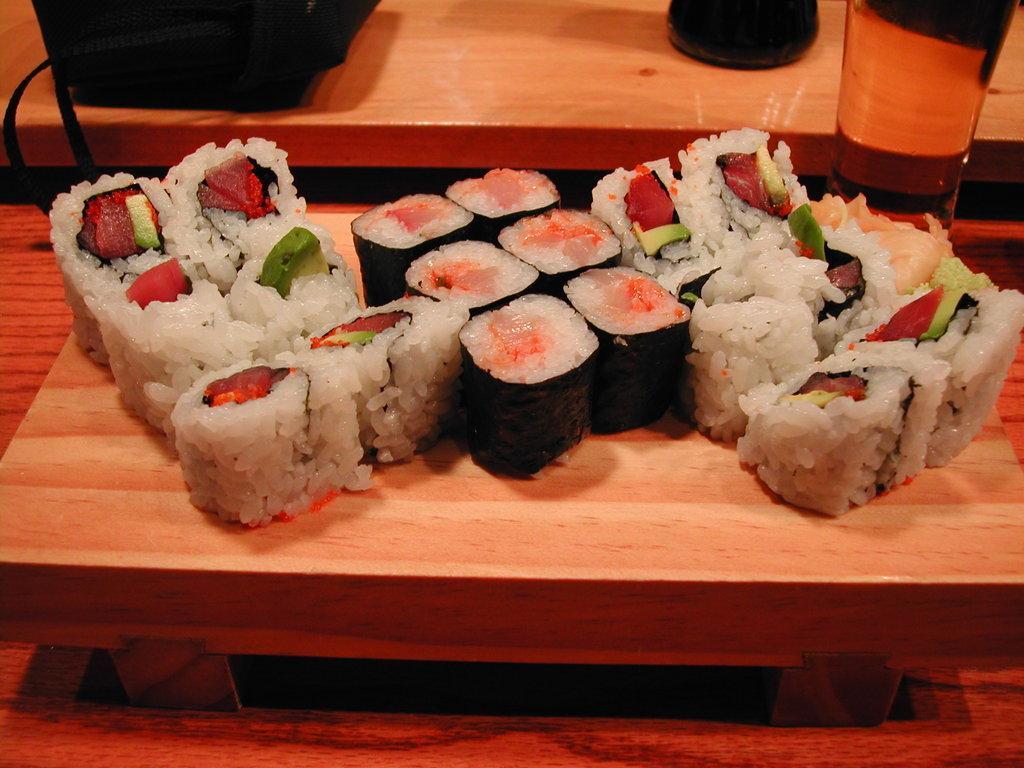Could you give a brief overview of what you see in this image? In this image, we can see a table. In the middle of the table, we can see another table, on that table, we can see some food items. In the background, we can also see another table, on that table, we can see some objects which are placed. 